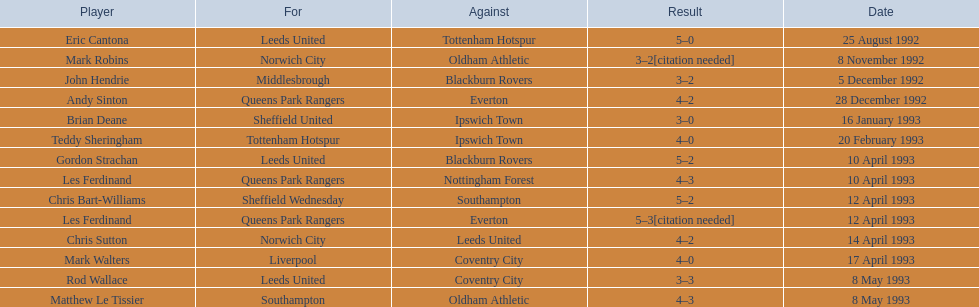Who are the players in 1992-93 fa premier league? Eric Cantona, Mark Robins, John Hendrie, Andy Sinton, Brian Deane, Teddy Sheringham, Gordon Strachan, Les Ferdinand, Chris Bart-Williams, Les Ferdinand, Chris Sutton, Mark Walters, Rod Wallace, Matthew Le Tissier. What is mark robins' result? 3–2[citation needed]. Which player has the same result? John Hendrie. 